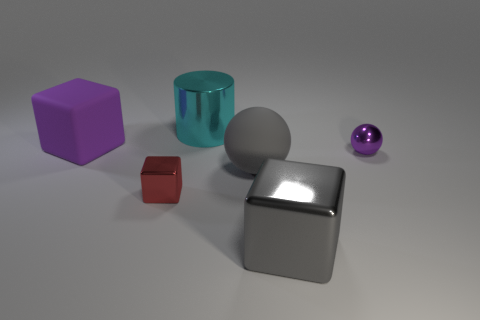Subtract all red metallic cubes. How many cubes are left? 2 Add 1 tiny cylinders. How many objects exist? 7 Subtract all cylinders. How many objects are left? 5 Subtract all small yellow blocks. Subtract all small purple shiny things. How many objects are left? 5 Add 3 cyan metal cylinders. How many cyan metal cylinders are left? 4 Add 3 tiny blue rubber balls. How many tiny blue rubber balls exist? 3 Subtract 0 brown spheres. How many objects are left? 6 